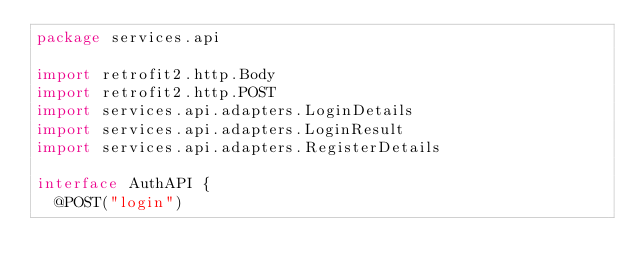<code> <loc_0><loc_0><loc_500><loc_500><_Kotlin_>package services.api

import retrofit2.http.Body
import retrofit2.http.POST
import services.api.adapters.LoginDetails
import services.api.adapters.LoginResult
import services.api.adapters.RegisterDetails

interface AuthAPI {
  @POST("login")</code> 